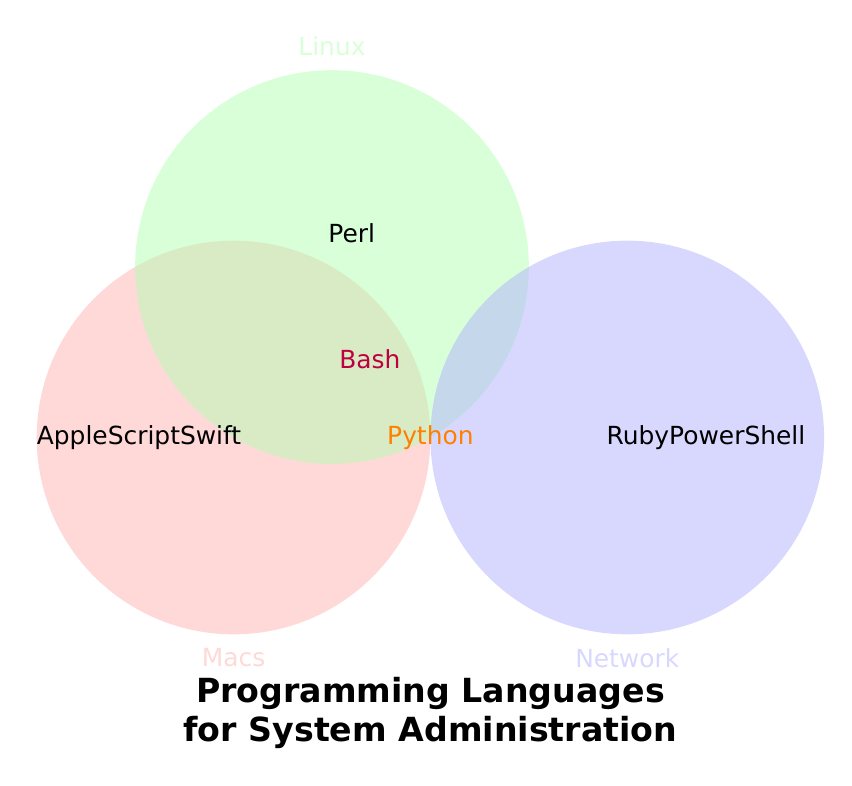What's the title of the figure? The title is placed at the bottom center of the figure in larger, bold font.
Answer: Programming Languages for System Administration What languages are exclusive to Macs? The region only covered by the red circle represents Macs, showing two languages.
Answer: AppleScript, Swift Which language is unique to Linux? The region only covered by the green circle represents Linux, showing one language.
Answer: Perl Which languages are used in both Macs and Linux but not Network? The overlapping region of the red and green circles, but excluding the blue circle, has one language.
Answer: Bash How many languages are shared between all three categories? The center overlapping region of all three circles contains one text.
Answer: Python Which color represents the Network category? The figure shows three circles, each having different colors. The blue circle is labeled Network.
Answer: Blue How many languages are mentioned in the Network category, excluding overlaps with other categories? The region only covered by the blue circle represents Network, showing two languages.
Answer: Two What language is used across Macs, Linux, and Network categories? The figure shows one language in the overlapping region of all three circles.
Answer: Python Compare the number of languages unique to Macs versus unique to Linux. The red circle (Macs) has two unique languages, and the green circle (Linux) has one unique language.
Answer: Macs: 2, Linux: 1 Which language is shared between Macs and Network but not Linux? The overlapping region of the red and blue circles, excluding the green circle, has no language listed.
Answer: None 